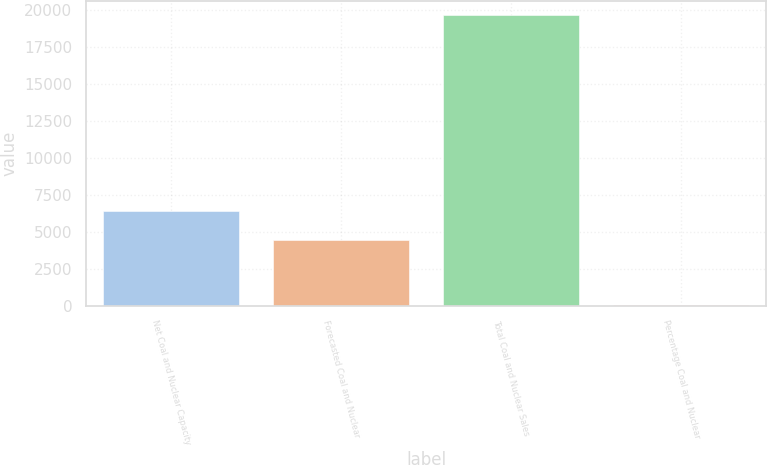<chart> <loc_0><loc_0><loc_500><loc_500><bar_chart><fcel>Net Coal and Nuclear Capacity<fcel>Forecasted Coal and Nuclear<fcel>Total Coal and Nuclear Sales<fcel>Percentage Coal and Nuclear<nl><fcel>6368.3<fcel>4411<fcel>19624<fcel>51<nl></chart> 